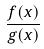Convert formula to latex. <formula><loc_0><loc_0><loc_500><loc_500>\frac { f ( x ) } { g ( x ) }</formula> 